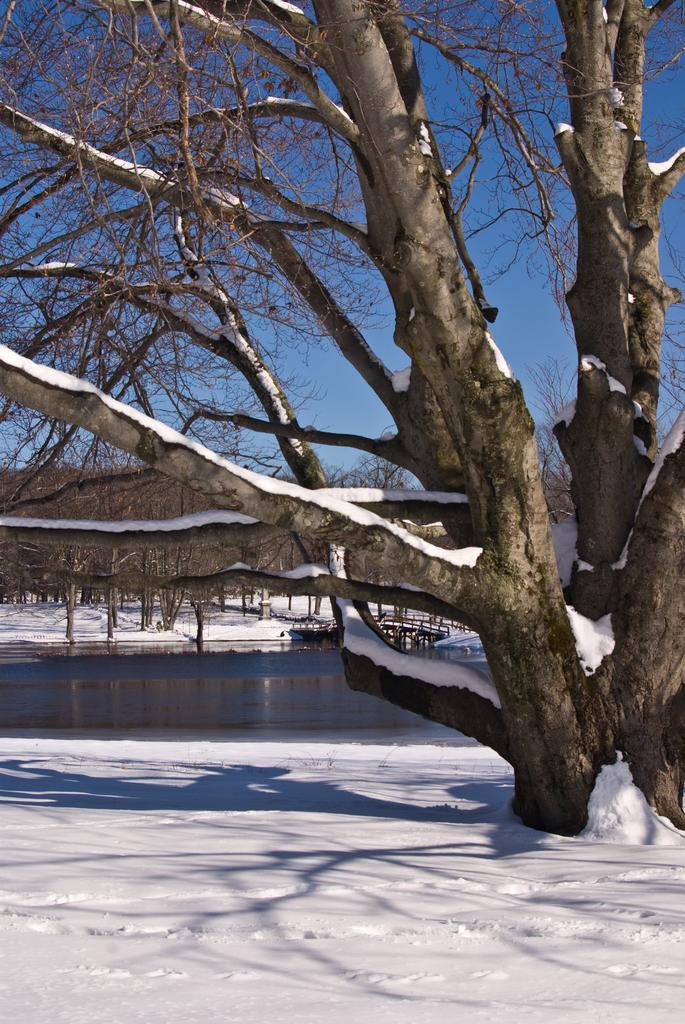What type of vegetation can be seen in the image? There are trees in the image. What structure is present in the image? There is a bridge in the image. What is visible at the top of the image? The sky is visible at the top of the image. What is present at the bottom of the image? There is snow and water at the bottom of the image. How are the trees affected by the snow in the image? Snow is present on the trees. Can you see a tiger walking on the bridge in the image? There is no tiger present in the image, and no animals are visible on the bridge. What type of gate can be seen at the entrance of the bridge in the image? There is no gate present at the entrance of the bridge in the image. 